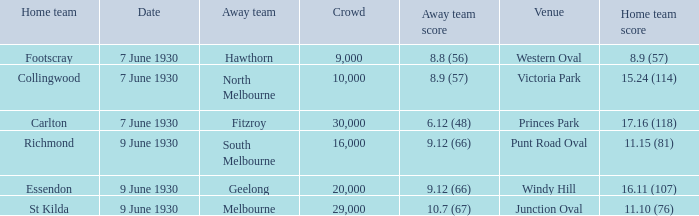7 (67)? 29000.0. 